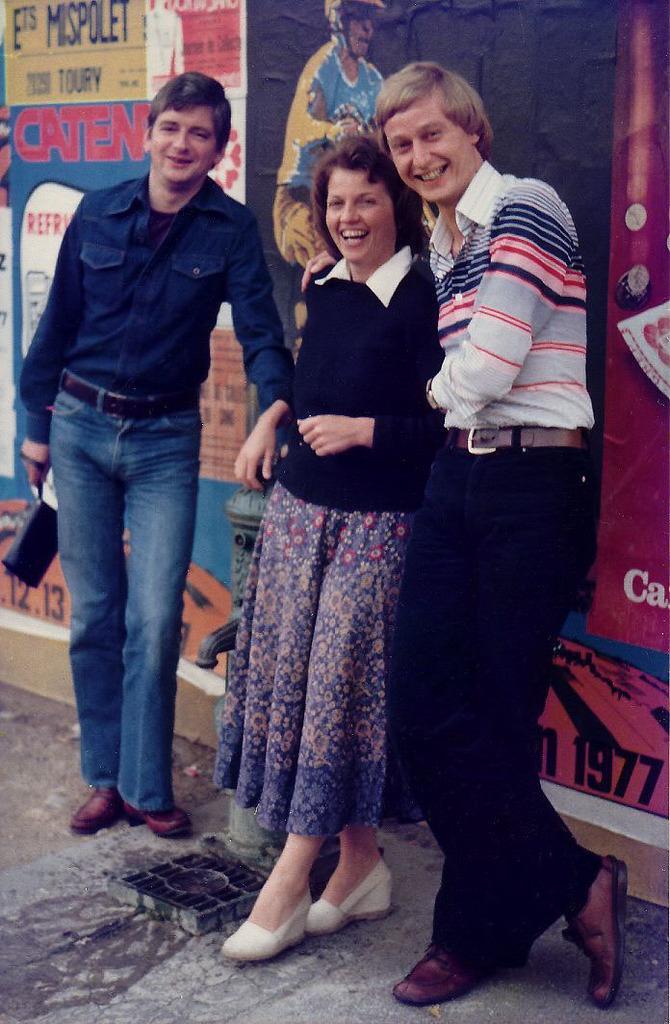Can you describe this image briefly? In this image we can see one woman and two men are standing and smiling. Woman is wearing blue color dress, one man is wearing blue shirt with jeans and the other one white t-shirt with black pant. Behind wall is there, on wall posters are pasted. 